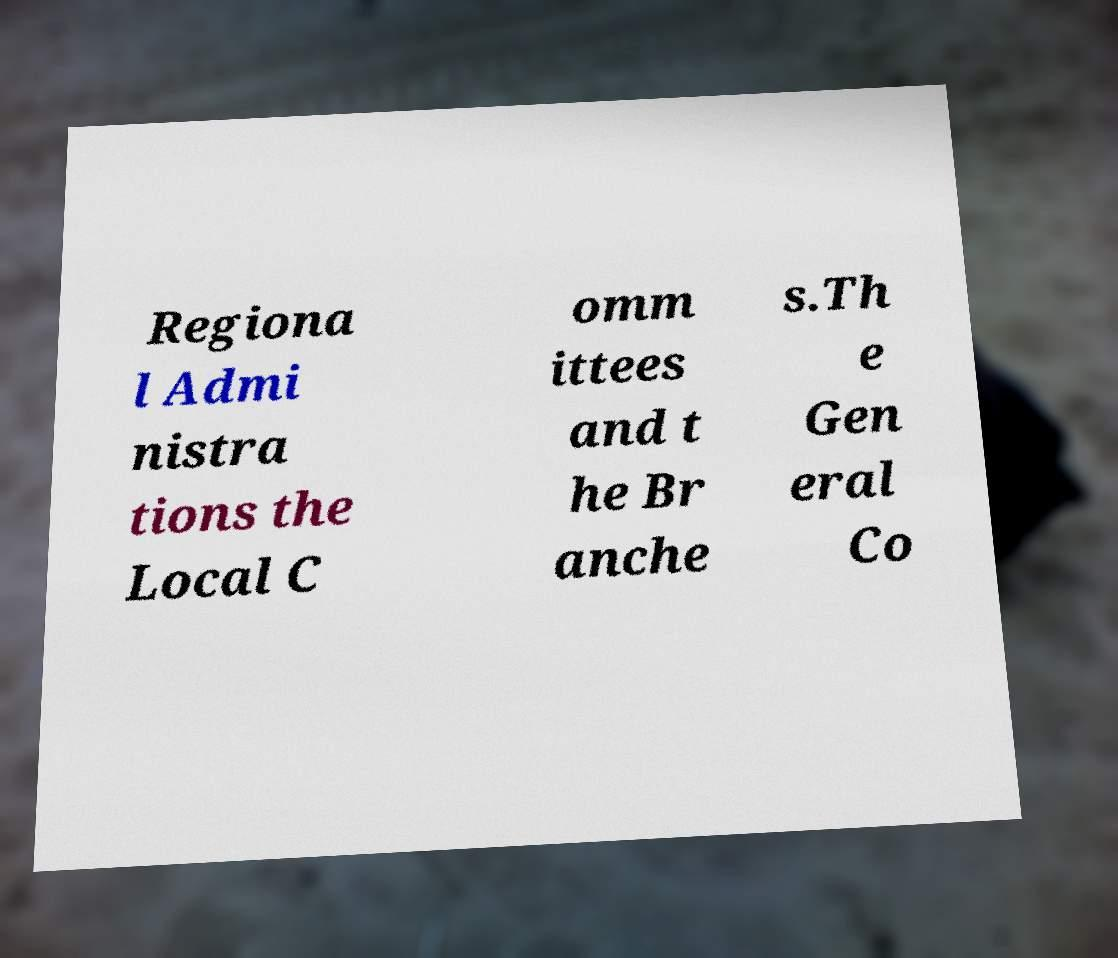Could you assist in decoding the text presented in this image and type it out clearly? Regiona l Admi nistra tions the Local C omm ittees and t he Br anche s.Th e Gen eral Co 